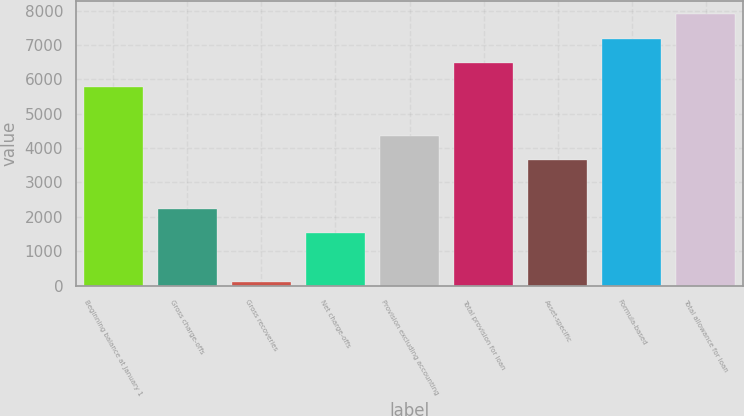Convert chart to OTSL. <chart><loc_0><loc_0><loc_500><loc_500><bar_chart><fcel>Beginning balance at January 1<fcel>Gross charge-offs<fcel>Gross recoveries<fcel>Net charge-offs<fcel>Provision excluding accounting<fcel>Total provision for loan<fcel>Asset-specific<fcel>Formula-based<fcel>Total allowance for loan<nl><fcel>5767<fcel>2237<fcel>119<fcel>1531<fcel>4355<fcel>6473<fcel>3649<fcel>7179<fcel>7885<nl></chart> 